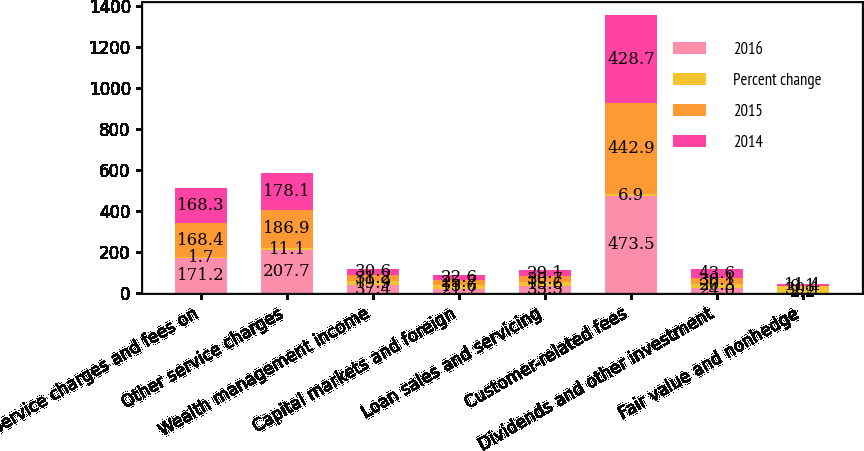Convert chart. <chart><loc_0><loc_0><loc_500><loc_500><stacked_bar_chart><ecel><fcel>Service charges and fees on<fcel>Other service charges<fcel>Wealth management income<fcel>Capital markets and foreign<fcel>Loan sales and servicing<fcel>Customer-related fees<fcel>Dividends and other investment<fcel>Fair value and nonhedge<nl><fcel>2016<fcel>171.2<fcel>207.7<fcel>37.4<fcel>21.7<fcel>35.5<fcel>473.5<fcel>24<fcel>2.2<nl><fcel>Percent change<fcel>1.7<fcel>11.1<fcel>19.9<fcel>15.6<fcel>15.6<fcel>6.9<fcel>20.3<fcel>30.1<nl><fcel>2015<fcel>168.4<fcel>186.9<fcel>31.2<fcel>25.7<fcel>30.7<fcel>442.9<fcel>30.1<fcel>0.1<nl><fcel>2014<fcel>168.3<fcel>178.1<fcel>30.6<fcel>22.6<fcel>29.1<fcel>428.7<fcel>43.6<fcel>11.4<nl></chart> 